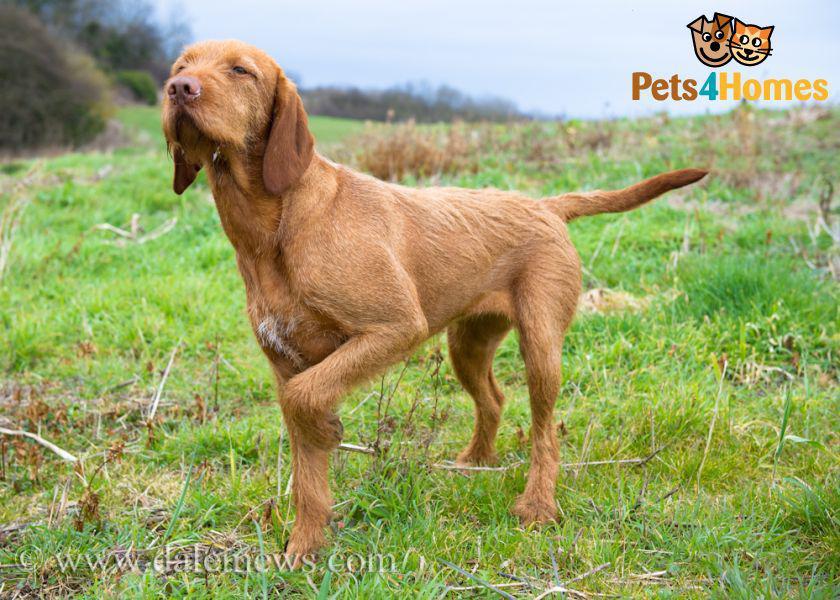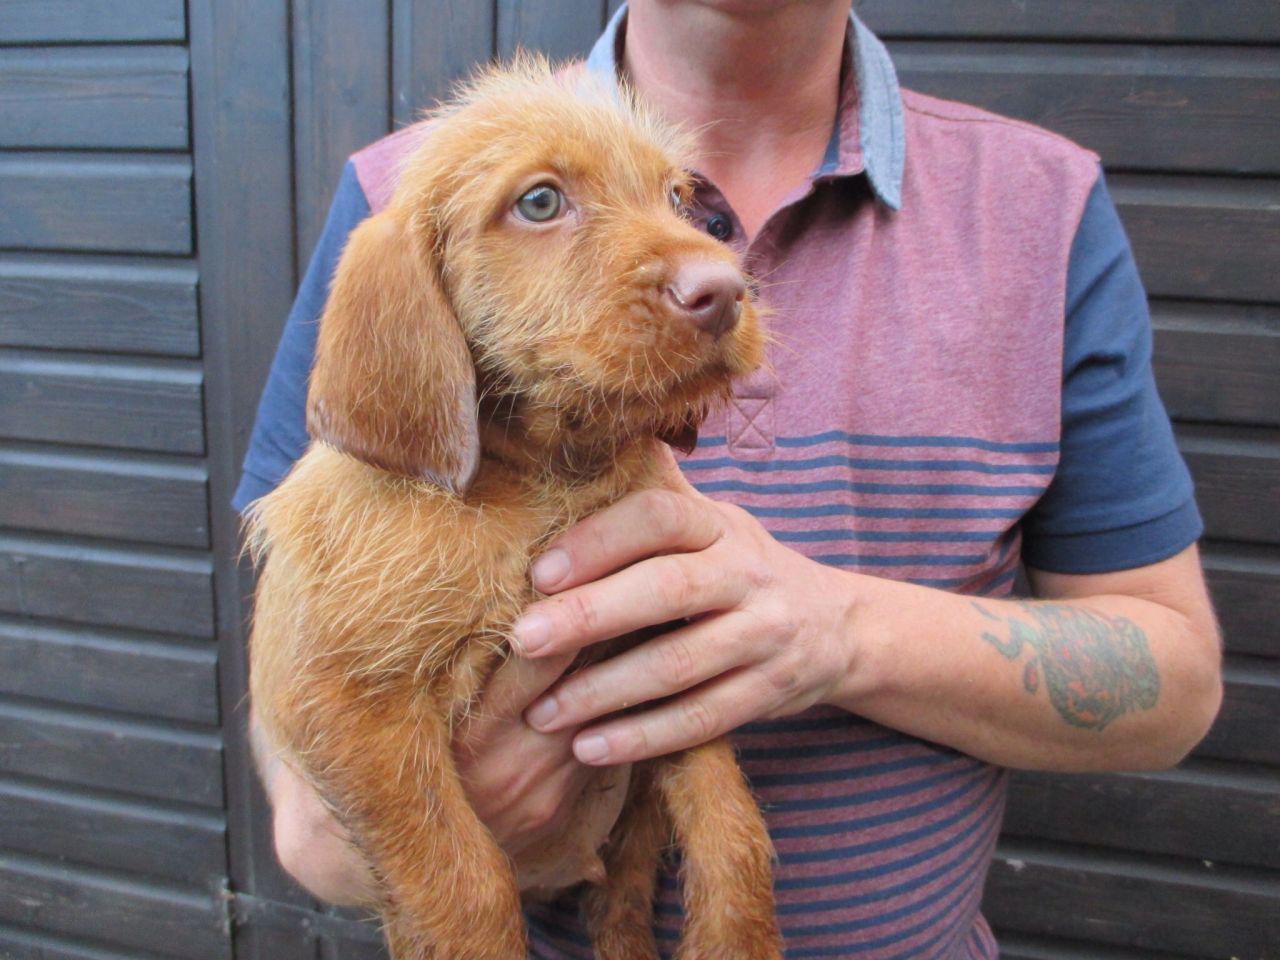The first image is the image on the left, the second image is the image on the right. For the images displayed, is the sentence "There is a total of two dogs with one sitting and one standing." factually correct? Answer yes or no. No. The first image is the image on the left, the second image is the image on the right. Examine the images to the left and right. Is the description "In one image, a dog is standing with one of its paws lifted up off the ground." accurate? Answer yes or no. Yes. 